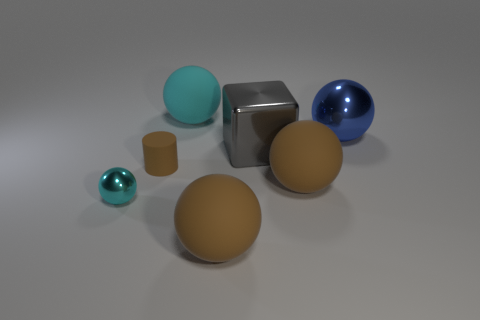How big is the cube?
Make the answer very short. Large. What is the material of the blue ball?
Keep it short and to the point. Metal. There is a sphere on the left side of the cyan matte ball; does it have the same size as the cube?
Offer a very short reply. No. How many objects are either brown matte cylinders or cyan spheres?
Offer a very short reply. 3. There is a large rubber thing that is the same color as the small shiny ball; what shape is it?
Offer a terse response. Sphere. There is a matte sphere that is in front of the large cyan sphere and behind the small shiny ball; what is its size?
Make the answer very short. Large. What number of large blocks are there?
Your answer should be very brief. 1. What number of spheres are tiny rubber objects or big cyan matte things?
Offer a terse response. 1. How many big cyan rubber objects are to the left of the matte thing that is in front of the cyan ball that is in front of the gray cube?
Provide a succinct answer. 1. What is the color of the other metallic object that is the same size as the blue object?
Provide a succinct answer. Gray. 